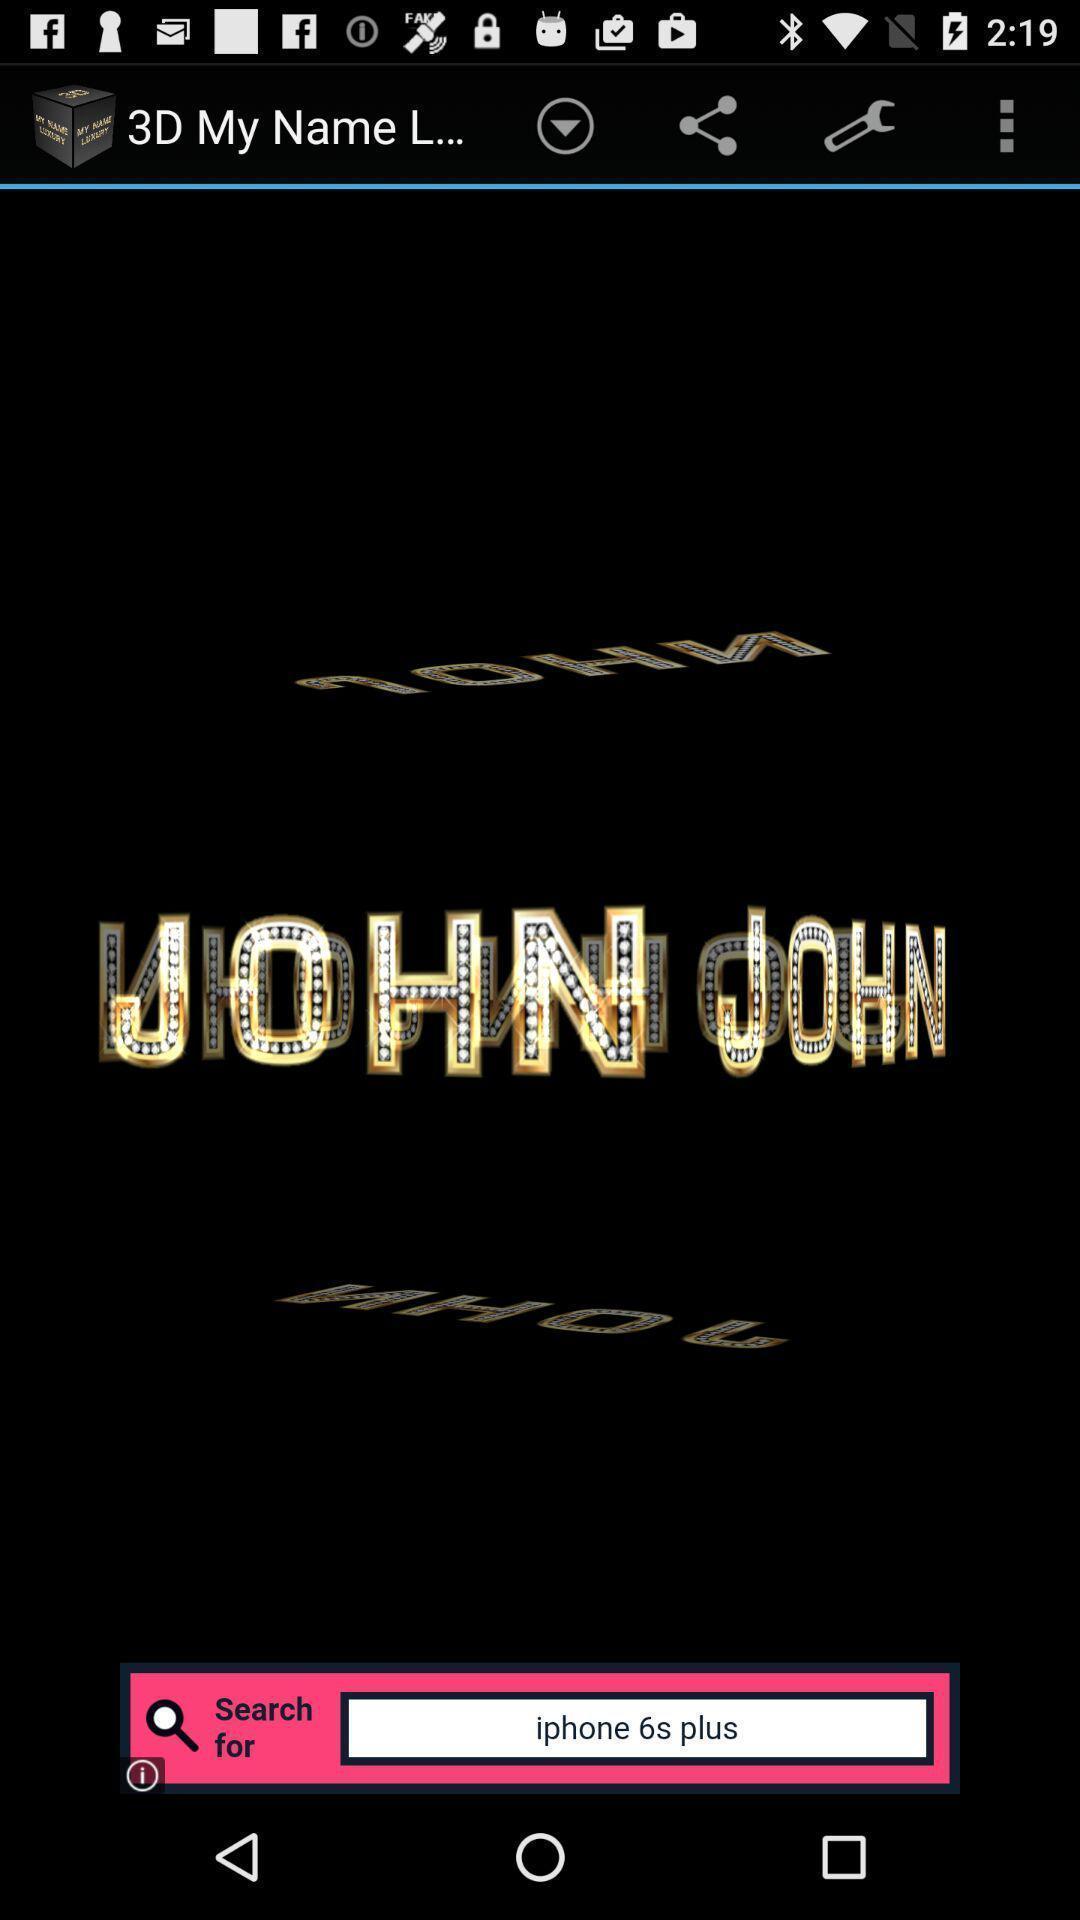Explain what's happening in this screen capture. Page showing your name in the names editing app. 